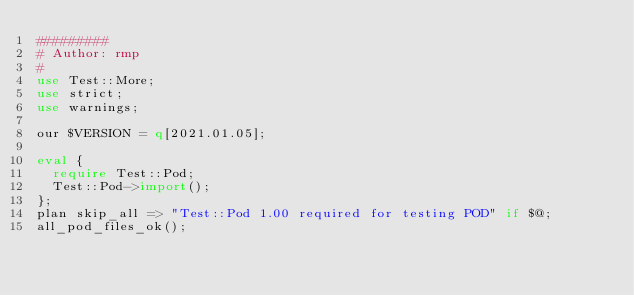Convert code to text. <code><loc_0><loc_0><loc_500><loc_500><_Perl_>#########
# Author: rmp
#
use Test::More;
use strict;
use warnings;

our $VERSION = q[2021.01.05];

eval {
  require Test::Pod;
  Test::Pod->import();
};
plan skip_all => "Test::Pod 1.00 required for testing POD" if $@;
all_pod_files_ok();

</code> 